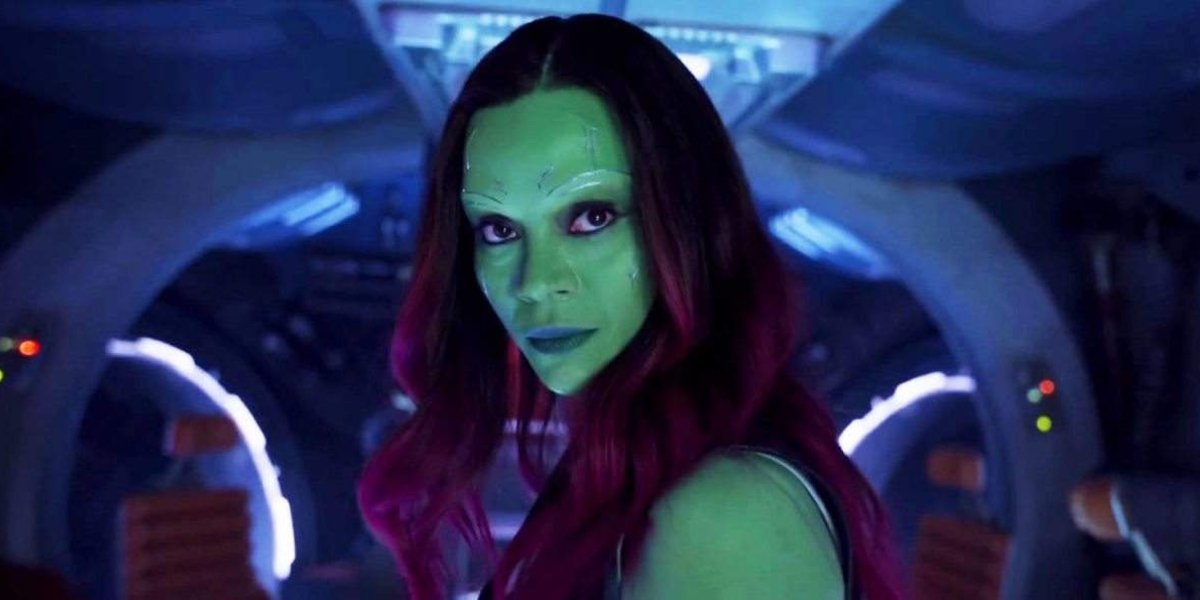What can you tell me about the mood conveyed by the character's expression and the surrounding lighting? The character's serious expression coupled with the strategic use of shadowing and contrasting vibrant lighting creates a mood of intensity and suspense. This could indicate her readiness for an impending conflict or a moment of significant decision-making in her storyline. 